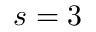<formula> <loc_0><loc_0><loc_500><loc_500>s = 3</formula> 